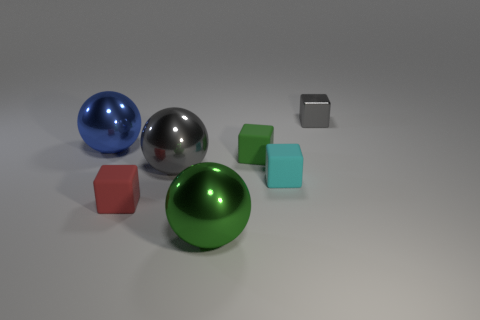Add 2 big cylinders. How many objects exist? 9 Subtract all tiny shiny blocks. How many blocks are left? 3 Subtract 2 balls. How many balls are left? 1 Subtract all spheres. How many objects are left? 4 Subtract all blue balls. How many balls are left? 2 Subtract 1 gray blocks. How many objects are left? 6 Subtract all red spheres. Subtract all purple cylinders. How many spheres are left? 3 Subtract all blue cubes. How many purple spheres are left? 0 Subtract all small gray objects. Subtract all small gray blocks. How many objects are left? 5 Add 4 blue metal things. How many blue metal things are left? 5 